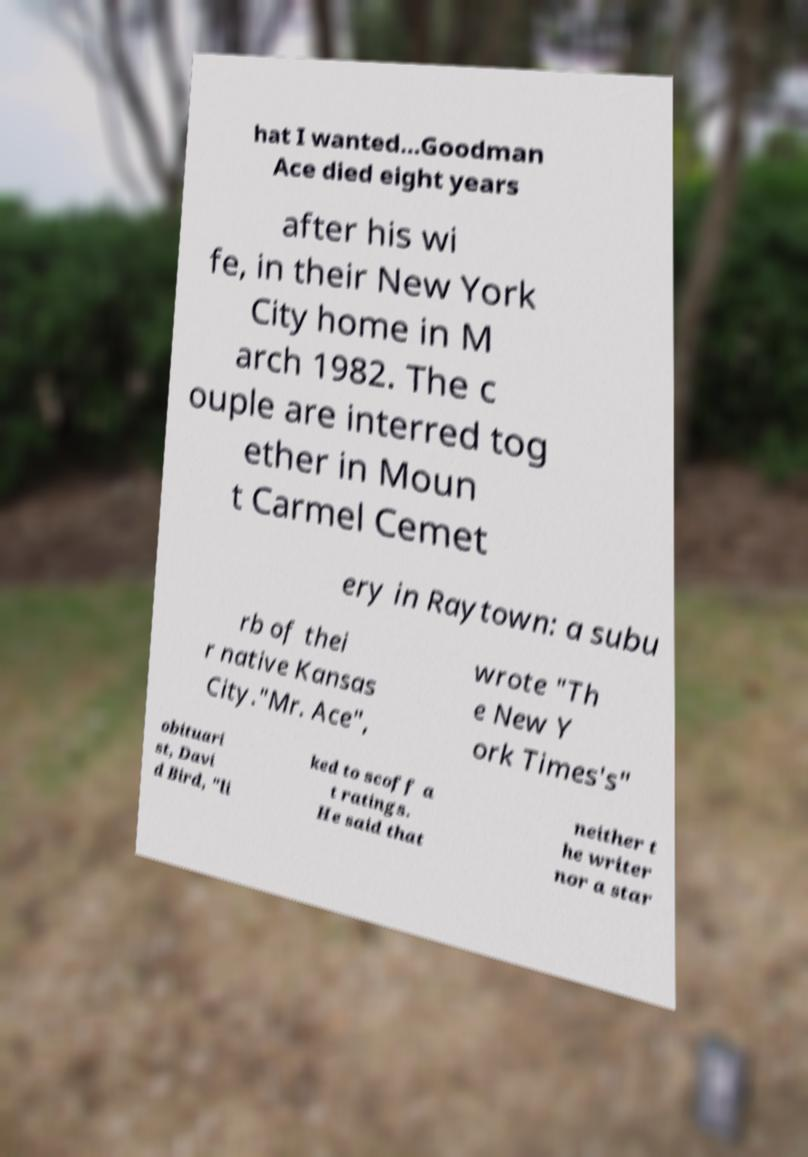Could you assist in decoding the text presented in this image and type it out clearly? hat I wanted...Goodman Ace died eight years after his wi fe, in their New York City home in M arch 1982. The c ouple are interred tog ether in Moun t Carmel Cemet ery in Raytown: a subu rb of thei r native Kansas City."Mr. Ace", wrote "Th e New Y ork Times's" obituari st, Davi d Bird, "li ked to scoff a t ratings. He said that neither t he writer nor a star 